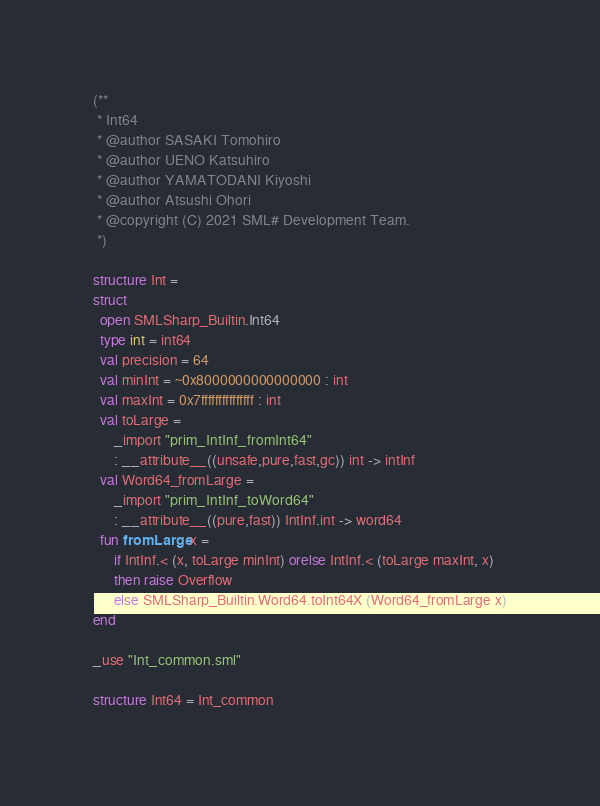<code> <loc_0><loc_0><loc_500><loc_500><_SML_>(**
 * Int64
 * @author SASAKI Tomohiro
 * @author UENO Katsuhiro
 * @author YAMATODANI Kiyoshi
 * @author Atsushi Ohori
 * @copyright (C) 2021 SML# Development Team.
 *)

structure Int =
struct
  open SMLSharp_Builtin.Int64
  type int = int64
  val precision = 64
  val minInt = ~0x8000000000000000 : int
  val maxInt = 0x7fffffffffffffff : int
  val toLarge =
      _import "prim_IntInf_fromInt64"
      : __attribute__((unsafe,pure,fast,gc)) int -> intInf
  val Word64_fromLarge =
      _import "prim_IntInf_toWord64"
      : __attribute__((pure,fast)) IntInf.int -> word64
  fun fromLarge x =
      if IntInf.< (x, toLarge minInt) orelse IntInf.< (toLarge maxInt, x)
      then raise Overflow
      else SMLSharp_Builtin.Word64.toInt64X (Word64_fromLarge x)
end

_use "Int_common.sml"

structure Int64 = Int_common
</code> 